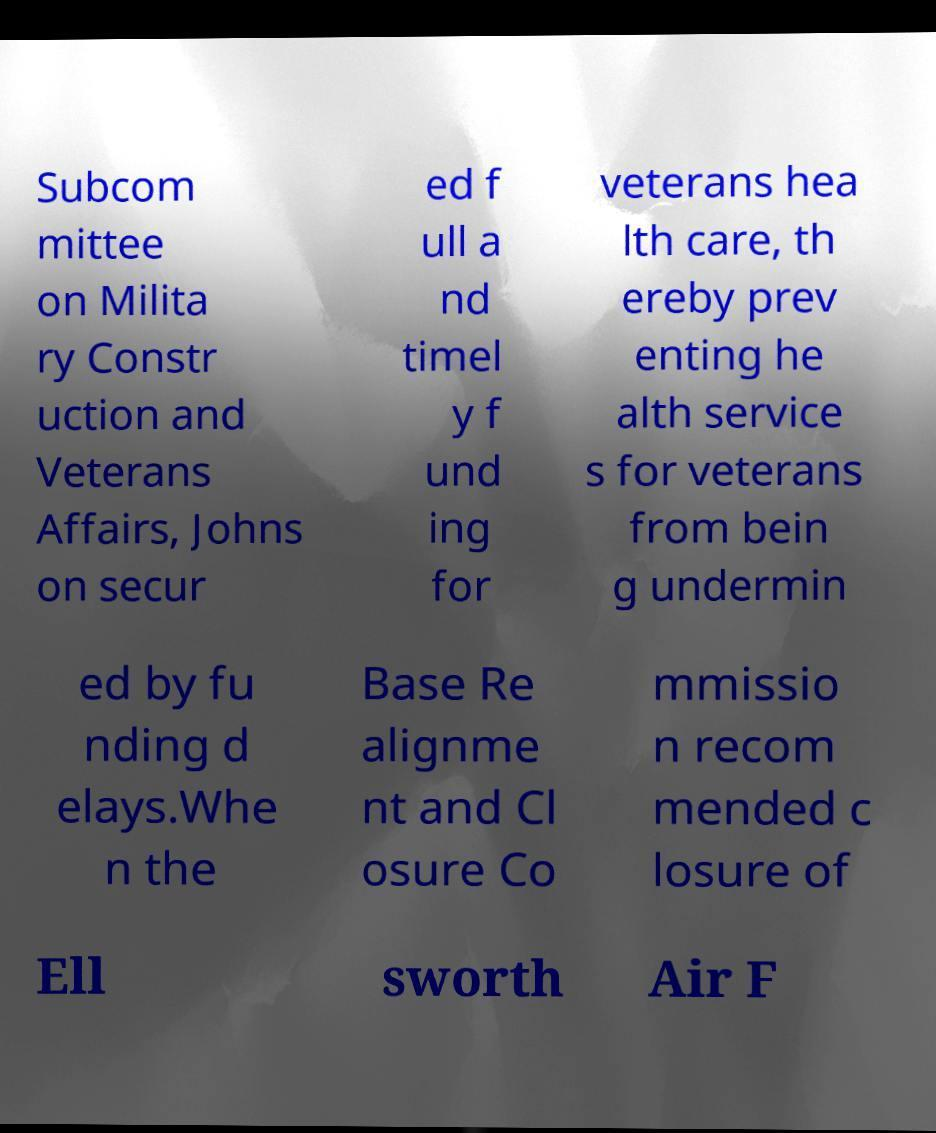Can you read and provide the text displayed in the image?This photo seems to have some interesting text. Can you extract and type it out for me? Subcom mittee on Milita ry Constr uction and Veterans Affairs, Johns on secur ed f ull a nd timel y f und ing for veterans hea lth care, th ereby prev enting he alth service s for veterans from bein g undermin ed by fu nding d elays.Whe n the Base Re alignme nt and Cl osure Co mmissio n recom mended c losure of Ell sworth Air F 